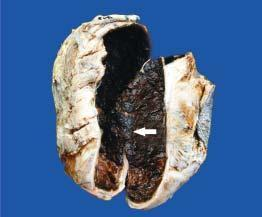does sectioned surface of the sac show thick wall coated internally by brownish, tan and necrotic material which is organised blood clot arrow?
Answer the question using a single word or phrase. Yes 